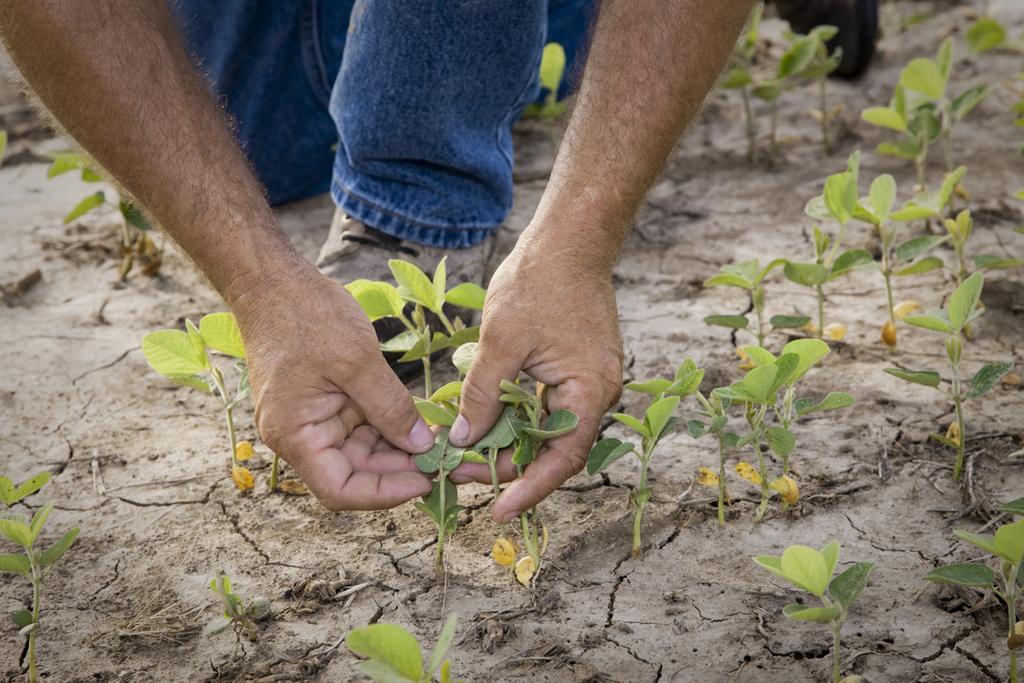In one or two sentences, can you explain what this image depicts? In this picture we can see planets on the ground and a person holding plants. 